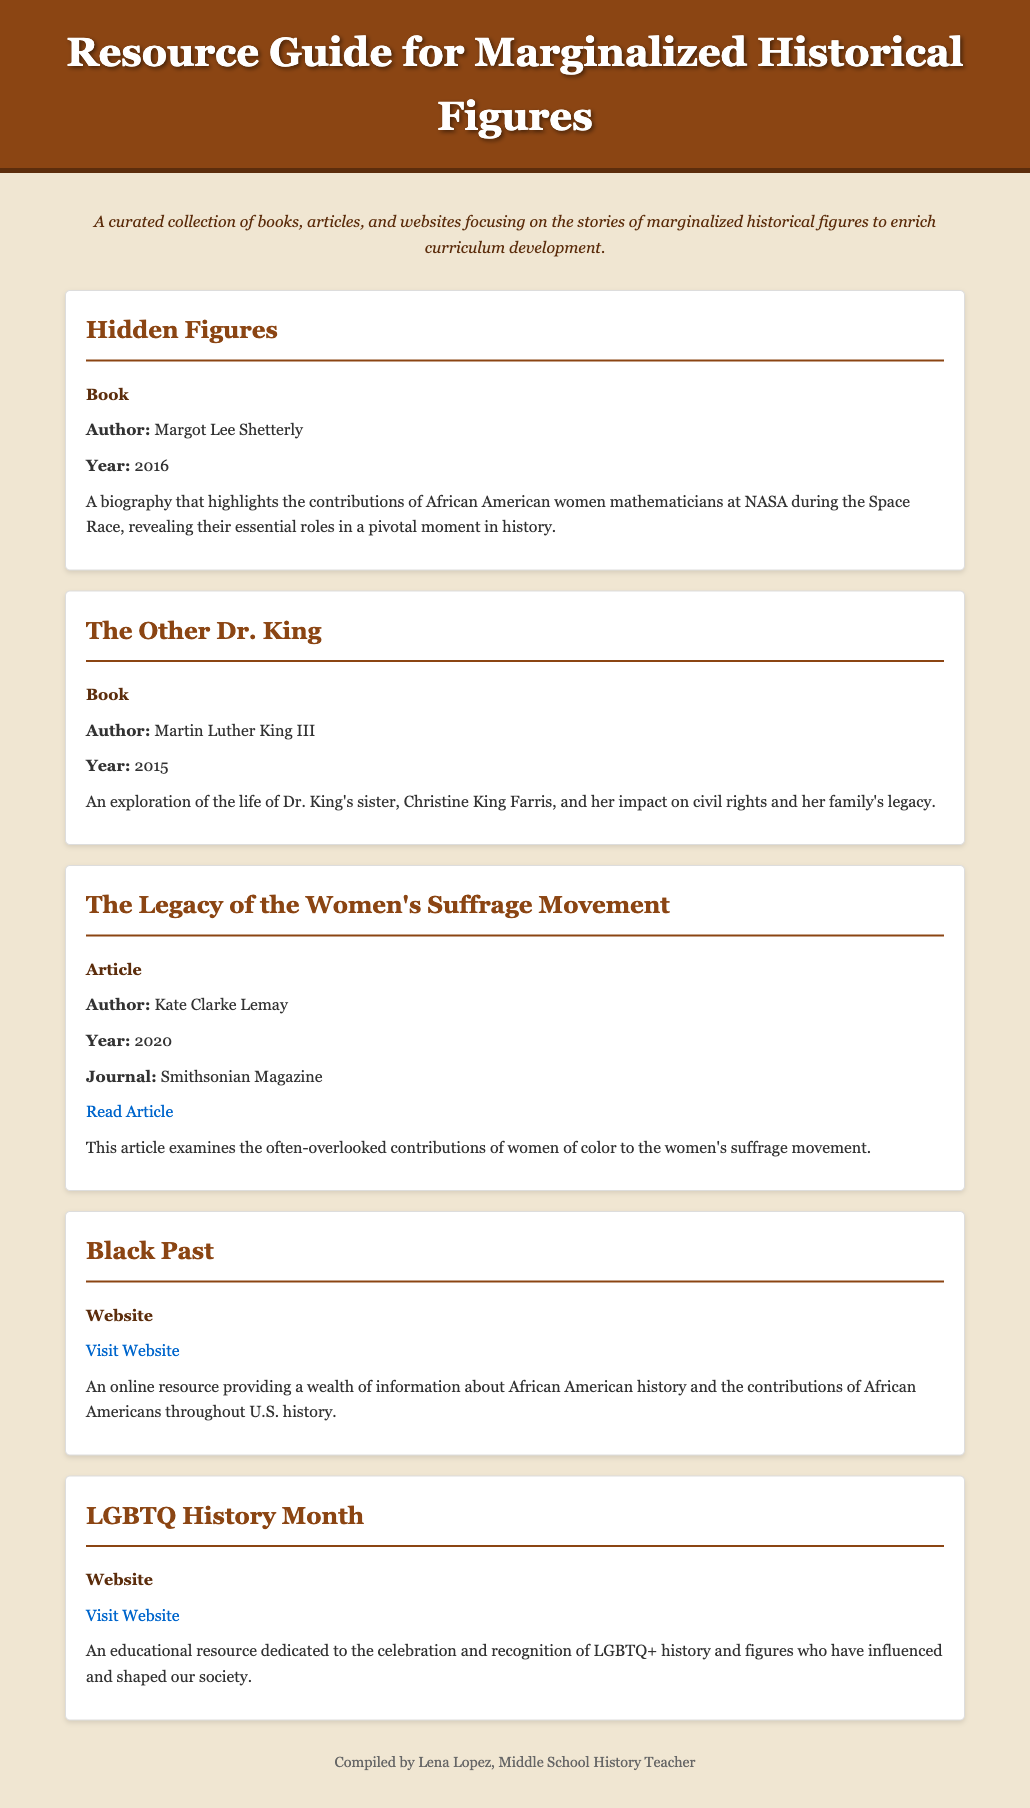What is the title of the first resource listed? The title of the first resource is located in a header under the resource section.
Answer: Hidden Figures Who is the author of "The Other Dr. King"? The author's name is mentioned directly under the resource title.
Answer: Martin Luther King III What year was "Hidden Figures" published? The publication year is stated below the author's name in the resource section.
Answer: 2016 What type of resource is "The Legacy of the Women's Suffrage Movement"? The type of resource is specified in bold in the resource section.
Answer: Article Which website provides information about African American history? The relevant website is introduced in the resource section as a source of information.
Answer: Black Past What are the contributions of women of color discussed in the article by Kate Clarke Lemay? The contributions mentioned are directly related to the women’s suffrage movement as outlined in the article.
Answer: Women's suffrage movement How many resources are in the guide? The total count can be found by identifying the number of resource sections present in the document.
Answer: 5 Which publication year is associated with "The Legacy of the Women's Suffrage Movement"? The year is indicated right after the author's name within the resource description.
Answer: 2020 What is the focus of LGBTQ History Month website? The description explains the purpose and focus of this educational resource.
Answer: Celebration and recognition of LGBTQ+ history 